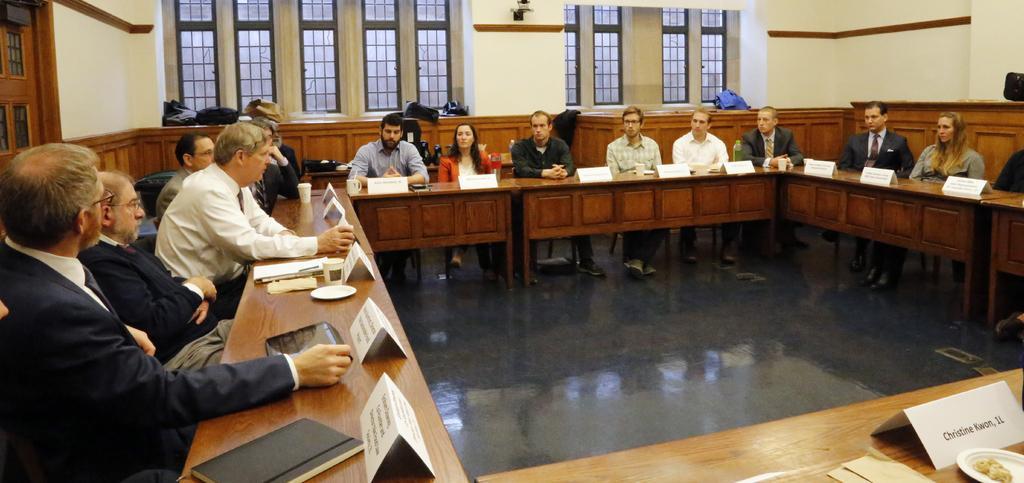Could you give a brief overview of what you see in this image? This picture is clicked inside a room. There are group of people sitting on chairs at the table. On the table there are name boards, glasses, cups, plates, books and tabletoids. Behind them there is another table on which bags are placed. In the background there is wall and windows. 